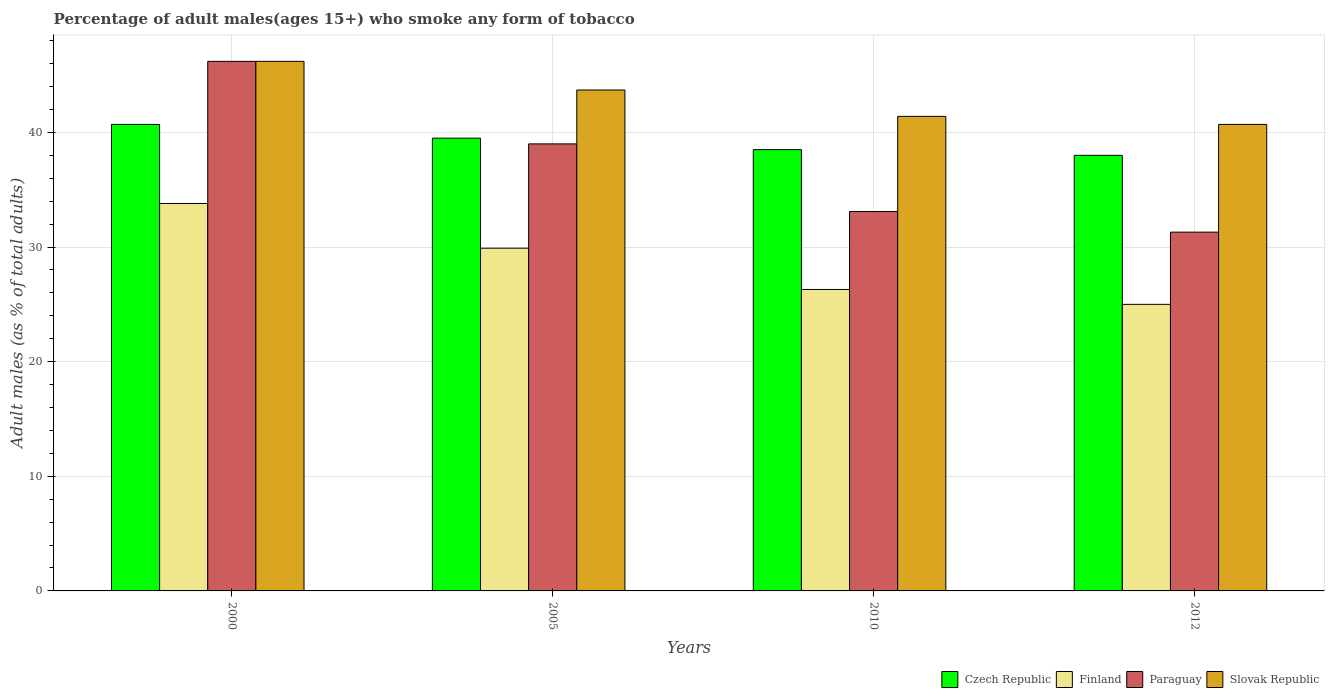How many different coloured bars are there?
Provide a short and direct response. 4. Are the number of bars on each tick of the X-axis equal?
Your answer should be compact. Yes. How many bars are there on the 2nd tick from the left?
Give a very brief answer. 4. How many bars are there on the 3rd tick from the right?
Keep it short and to the point. 4. In how many cases, is the number of bars for a given year not equal to the number of legend labels?
Your answer should be compact. 0. What is the percentage of adult males who smoke in Slovak Republic in 2005?
Offer a terse response. 43.7. Across all years, what is the maximum percentage of adult males who smoke in Czech Republic?
Ensure brevity in your answer.  40.7. Across all years, what is the minimum percentage of adult males who smoke in Slovak Republic?
Offer a very short reply. 40.7. In which year was the percentage of adult males who smoke in Czech Republic maximum?
Your answer should be very brief. 2000. What is the total percentage of adult males who smoke in Paraguay in the graph?
Give a very brief answer. 149.6. What is the difference between the percentage of adult males who smoke in Slovak Republic in 2010 and that in 2012?
Your response must be concise. 0.7. What is the difference between the percentage of adult males who smoke in Slovak Republic in 2010 and the percentage of adult males who smoke in Finland in 2005?
Offer a very short reply. 11.5. What is the average percentage of adult males who smoke in Czech Republic per year?
Your answer should be compact. 39.17. In the year 2010, what is the difference between the percentage of adult males who smoke in Finland and percentage of adult males who smoke in Slovak Republic?
Provide a succinct answer. -15.1. In how many years, is the percentage of adult males who smoke in Slovak Republic greater than 12 %?
Provide a succinct answer. 4. What is the ratio of the percentage of adult males who smoke in Slovak Republic in 2000 to that in 2005?
Ensure brevity in your answer.  1.06. What is the difference between the highest and the second highest percentage of adult males who smoke in Finland?
Make the answer very short. 3.9. What is the difference between the highest and the lowest percentage of adult males who smoke in Paraguay?
Provide a short and direct response. 14.9. Is the sum of the percentage of adult males who smoke in Czech Republic in 2010 and 2012 greater than the maximum percentage of adult males who smoke in Paraguay across all years?
Provide a succinct answer. Yes. Is it the case that in every year, the sum of the percentage of adult males who smoke in Finland and percentage of adult males who smoke in Czech Republic is greater than the sum of percentage of adult males who smoke in Paraguay and percentage of adult males who smoke in Slovak Republic?
Make the answer very short. No. What does the 3rd bar from the left in 2012 represents?
Keep it short and to the point. Paraguay. What does the 4th bar from the right in 2010 represents?
Provide a succinct answer. Czech Republic. How many bars are there?
Keep it short and to the point. 16. How many years are there in the graph?
Offer a terse response. 4. Does the graph contain any zero values?
Give a very brief answer. No. Does the graph contain grids?
Provide a short and direct response. Yes. How are the legend labels stacked?
Keep it short and to the point. Horizontal. What is the title of the graph?
Your answer should be very brief. Percentage of adult males(ages 15+) who smoke any form of tobacco. Does "Northern Mariana Islands" appear as one of the legend labels in the graph?
Your answer should be very brief. No. What is the label or title of the X-axis?
Provide a succinct answer. Years. What is the label or title of the Y-axis?
Ensure brevity in your answer.  Adult males (as % of total adults). What is the Adult males (as % of total adults) of Czech Republic in 2000?
Your response must be concise. 40.7. What is the Adult males (as % of total adults) in Finland in 2000?
Your answer should be compact. 33.8. What is the Adult males (as % of total adults) of Paraguay in 2000?
Offer a terse response. 46.2. What is the Adult males (as % of total adults) of Slovak Republic in 2000?
Your answer should be very brief. 46.2. What is the Adult males (as % of total adults) in Czech Republic in 2005?
Provide a short and direct response. 39.5. What is the Adult males (as % of total adults) in Finland in 2005?
Your answer should be very brief. 29.9. What is the Adult males (as % of total adults) in Paraguay in 2005?
Your answer should be very brief. 39. What is the Adult males (as % of total adults) of Slovak Republic in 2005?
Your response must be concise. 43.7. What is the Adult males (as % of total adults) in Czech Republic in 2010?
Offer a very short reply. 38.5. What is the Adult males (as % of total adults) of Finland in 2010?
Make the answer very short. 26.3. What is the Adult males (as % of total adults) in Paraguay in 2010?
Your answer should be compact. 33.1. What is the Adult males (as % of total adults) in Slovak Republic in 2010?
Give a very brief answer. 41.4. What is the Adult males (as % of total adults) of Czech Republic in 2012?
Your response must be concise. 38. What is the Adult males (as % of total adults) of Paraguay in 2012?
Provide a short and direct response. 31.3. What is the Adult males (as % of total adults) in Slovak Republic in 2012?
Offer a very short reply. 40.7. Across all years, what is the maximum Adult males (as % of total adults) in Czech Republic?
Your answer should be compact. 40.7. Across all years, what is the maximum Adult males (as % of total adults) in Finland?
Your answer should be compact. 33.8. Across all years, what is the maximum Adult males (as % of total adults) in Paraguay?
Provide a short and direct response. 46.2. Across all years, what is the maximum Adult males (as % of total adults) in Slovak Republic?
Your response must be concise. 46.2. Across all years, what is the minimum Adult males (as % of total adults) of Czech Republic?
Make the answer very short. 38. Across all years, what is the minimum Adult males (as % of total adults) in Paraguay?
Give a very brief answer. 31.3. Across all years, what is the minimum Adult males (as % of total adults) in Slovak Republic?
Keep it short and to the point. 40.7. What is the total Adult males (as % of total adults) in Czech Republic in the graph?
Provide a succinct answer. 156.7. What is the total Adult males (as % of total adults) of Finland in the graph?
Provide a short and direct response. 115. What is the total Adult males (as % of total adults) in Paraguay in the graph?
Give a very brief answer. 149.6. What is the total Adult males (as % of total adults) of Slovak Republic in the graph?
Your answer should be compact. 172. What is the difference between the Adult males (as % of total adults) in Czech Republic in 2000 and that in 2005?
Make the answer very short. 1.2. What is the difference between the Adult males (as % of total adults) in Finland in 2000 and that in 2005?
Give a very brief answer. 3.9. What is the difference between the Adult males (as % of total adults) of Paraguay in 2000 and that in 2005?
Your response must be concise. 7.2. What is the difference between the Adult males (as % of total adults) of Finland in 2000 and that in 2010?
Give a very brief answer. 7.5. What is the difference between the Adult males (as % of total adults) of Slovak Republic in 2000 and that in 2010?
Your response must be concise. 4.8. What is the difference between the Adult males (as % of total adults) in Paraguay in 2000 and that in 2012?
Give a very brief answer. 14.9. What is the difference between the Adult males (as % of total adults) of Slovak Republic in 2000 and that in 2012?
Provide a succinct answer. 5.5. What is the difference between the Adult males (as % of total adults) in Czech Republic in 2005 and that in 2010?
Provide a succinct answer. 1. What is the difference between the Adult males (as % of total adults) of Finland in 2005 and that in 2010?
Offer a very short reply. 3.6. What is the difference between the Adult males (as % of total adults) in Paraguay in 2005 and that in 2010?
Ensure brevity in your answer.  5.9. What is the difference between the Adult males (as % of total adults) in Czech Republic in 2010 and that in 2012?
Keep it short and to the point. 0.5. What is the difference between the Adult males (as % of total adults) of Finland in 2010 and that in 2012?
Make the answer very short. 1.3. What is the difference between the Adult males (as % of total adults) of Czech Republic in 2000 and the Adult males (as % of total adults) of Finland in 2005?
Provide a short and direct response. 10.8. What is the difference between the Adult males (as % of total adults) in Czech Republic in 2000 and the Adult males (as % of total adults) in Slovak Republic in 2005?
Offer a terse response. -3. What is the difference between the Adult males (as % of total adults) in Finland in 2000 and the Adult males (as % of total adults) in Slovak Republic in 2005?
Give a very brief answer. -9.9. What is the difference between the Adult males (as % of total adults) of Czech Republic in 2000 and the Adult males (as % of total adults) of Slovak Republic in 2010?
Your answer should be very brief. -0.7. What is the difference between the Adult males (as % of total adults) of Finland in 2000 and the Adult males (as % of total adults) of Paraguay in 2010?
Ensure brevity in your answer.  0.7. What is the difference between the Adult males (as % of total adults) in Czech Republic in 2000 and the Adult males (as % of total adults) in Finland in 2012?
Offer a very short reply. 15.7. What is the difference between the Adult males (as % of total adults) of Czech Republic in 2000 and the Adult males (as % of total adults) of Paraguay in 2012?
Offer a very short reply. 9.4. What is the difference between the Adult males (as % of total adults) of Paraguay in 2000 and the Adult males (as % of total adults) of Slovak Republic in 2012?
Keep it short and to the point. 5.5. What is the difference between the Adult males (as % of total adults) in Czech Republic in 2005 and the Adult males (as % of total adults) in Finland in 2010?
Ensure brevity in your answer.  13.2. What is the difference between the Adult males (as % of total adults) in Czech Republic in 2005 and the Adult males (as % of total adults) in Paraguay in 2010?
Keep it short and to the point. 6.4. What is the difference between the Adult males (as % of total adults) of Czech Republic in 2005 and the Adult males (as % of total adults) of Slovak Republic in 2010?
Keep it short and to the point. -1.9. What is the difference between the Adult males (as % of total adults) of Finland in 2005 and the Adult males (as % of total adults) of Slovak Republic in 2010?
Keep it short and to the point. -11.5. What is the difference between the Adult males (as % of total adults) in Paraguay in 2005 and the Adult males (as % of total adults) in Slovak Republic in 2010?
Provide a succinct answer. -2.4. What is the difference between the Adult males (as % of total adults) in Czech Republic in 2005 and the Adult males (as % of total adults) in Finland in 2012?
Provide a succinct answer. 14.5. What is the difference between the Adult males (as % of total adults) in Czech Republic in 2005 and the Adult males (as % of total adults) in Slovak Republic in 2012?
Offer a very short reply. -1.2. What is the difference between the Adult males (as % of total adults) in Finland in 2005 and the Adult males (as % of total adults) in Paraguay in 2012?
Provide a succinct answer. -1.4. What is the difference between the Adult males (as % of total adults) of Finland in 2010 and the Adult males (as % of total adults) of Slovak Republic in 2012?
Ensure brevity in your answer.  -14.4. What is the average Adult males (as % of total adults) in Czech Republic per year?
Your answer should be very brief. 39.17. What is the average Adult males (as % of total adults) in Finland per year?
Offer a terse response. 28.75. What is the average Adult males (as % of total adults) in Paraguay per year?
Keep it short and to the point. 37.4. What is the average Adult males (as % of total adults) in Slovak Republic per year?
Offer a terse response. 43. In the year 2000, what is the difference between the Adult males (as % of total adults) of Czech Republic and Adult males (as % of total adults) of Finland?
Provide a succinct answer. 6.9. In the year 2000, what is the difference between the Adult males (as % of total adults) in Czech Republic and Adult males (as % of total adults) in Paraguay?
Your response must be concise. -5.5. In the year 2000, what is the difference between the Adult males (as % of total adults) of Czech Republic and Adult males (as % of total adults) of Slovak Republic?
Make the answer very short. -5.5. In the year 2000, what is the difference between the Adult males (as % of total adults) in Paraguay and Adult males (as % of total adults) in Slovak Republic?
Keep it short and to the point. 0. In the year 2005, what is the difference between the Adult males (as % of total adults) of Czech Republic and Adult males (as % of total adults) of Finland?
Your response must be concise. 9.6. In the year 2005, what is the difference between the Adult males (as % of total adults) in Finland and Adult males (as % of total adults) in Paraguay?
Provide a short and direct response. -9.1. In the year 2005, what is the difference between the Adult males (as % of total adults) of Finland and Adult males (as % of total adults) of Slovak Republic?
Provide a succinct answer. -13.8. In the year 2010, what is the difference between the Adult males (as % of total adults) of Czech Republic and Adult males (as % of total adults) of Finland?
Your answer should be very brief. 12.2. In the year 2010, what is the difference between the Adult males (as % of total adults) of Czech Republic and Adult males (as % of total adults) of Paraguay?
Offer a terse response. 5.4. In the year 2010, what is the difference between the Adult males (as % of total adults) of Finland and Adult males (as % of total adults) of Slovak Republic?
Your response must be concise. -15.1. In the year 2012, what is the difference between the Adult males (as % of total adults) in Czech Republic and Adult males (as % of total adults) in Finland?
Offer a terse response. 13. In the year 2012, what is the difference between the Adult males (as % of total adults) of Czech Republic and Adult males (as % of total adults) of Slovak Republic?
Your response must be concise. -2.7. In the year 2012, what is the difference between the Adult males (as % of total adults) in Finland and Adult males (as % of total adults) in Slovak Republic?
Offer a terse response. -15.7. What is the ratio of the Adult males (as % of total adults) of Czech Republic in 2000 to that in 2005?
Make the answer very short. 1.03. What is the ratio of the Adult males (as % of total adults) of Finland in 2000 to that in 2005?
Your response must be concise. 1.13. What is the ratio of the Adult males (as % of total adults) in Paraguay in 2000 to that in 2005?
Provide a succinct answer. 1.18. What is the ratio of the Adult males (as % of total adults) in Slovak Republic in 2000 to that in 2005?
Give a very brief answer. 1.06. What is the ratio of the Adult males (as % of total adults) of Czech Republic in 2000 to that in 2010?
Make the answer very short. 1.06. What is the ratio of the Adult males (as % of total adults) of Finland in 2000 to that in 2010?
Make the answer very short. 1.29. What is the ratio of the Adult males (as % of total adults) of Paraguay in 2000 to that in 2010?
Keep it short and to the point. 1.4. What is the ratio of the Adult males (as % of total adults) in Slovak Republic in 2000 to that in 2010?
Your response must be concise. 1.12. What is the ratio of the Adult males (as % of total adults) in Czech Republic in 2000 to that in 2012?
Your answer should be very brief. 1.07. What is the ratio of the Adult males (as % of total adults) of Finland in 2000 to that in 2012?
Provide a short and direct response. 1.35. What is the ratio of the Adult males (as % of total adults) in Paraguay in 2000 to that in 2012?
Offer a terse response. 1.48. What is the ratio of the Adult males (as % of total adults) in Slovak Republic in 2000 to that in 2012?
Give a very brief answer. 1.14. What is the ratio of the Adult males (as % of total adults) in Finland in 2005 to that in 2010?
Give a very brief answer. 1.14. What is the ratio of the Adult males (as % of total adults) in Paraguay in 2005 to that in 2010?
Offer a very short reply. 1.18. What is the ratio of the Adult males (as % of total adults) of Slovak Republic in 2005 to that in 2010?
Provide a succinct answer. 1.06. What is the ratio of the Adult males (as % of total adults) of Czech Republic in 2005 to that in 2012?
Provide a succinct answer. 1.04. What is the ratio of the Adult males (as % of total adults) of Finland in 2005 to that in 2012?
Provide a succinct answer. 1.2. What is the ratio of the Adult males (as % of total adults) in Paraguay in 2005 to that in 2012?
Keep it short and to the point. 1.25. What is the ratio of the Adult males (as % of total adults) of Slovak Republic in 2005 to that in 2012?
Offer a very short reply. 1.07. What is the ratio of the Adult males (as % of total adults) of Czech Republic in 2010 to that in 2012?
Provide a short and direct response. 1.01. What is the ratio of the Adult males (as % of total adults) of Finland in 2010 to that in 2012?
Offer a very short reply. 1.05. What is the ratio of the Adult males (as % of total adults) of Paraguay in 2010 to that in 2012?
Offer a terse response. 1.06. What is the ratio of the Adult males (as % of total adults) of Slovak Republic in 2010 to that in 2012?
Keep it short and to the point. 1.02. What is the difference between the highest and the second highest Adult males (as % of total adults) of Finland?
Ensure brevity in your answer.  3.9. What is the difference between the highest and the lowest Adult males (as % of total adults) in Finland?
Provide a short and direct response. 8.8. What is the difference between the highest and the lowest Adult males (as % of total adults) in Paraguay?
Make the answer very short. 14.9. 